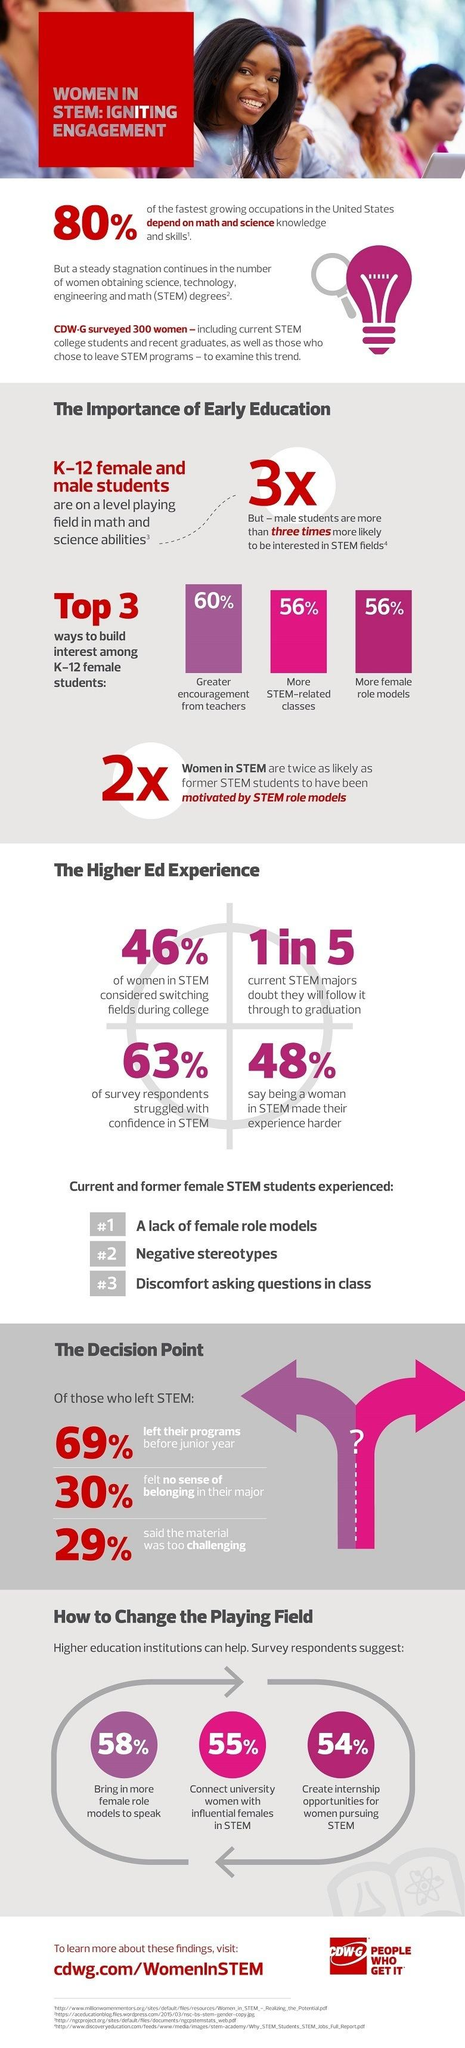List a handful of essential elements in this visual. According to a study, a significant percentage of STEM (Science, Technology, Engineering, and Mathematics) graduates quit their course in the initial year itself, with 69% of them doing so. The third problem faced by STEM graduates is difficulty in feeling comfortable asking questions in class. The second problem faced by STEM graduates is the prevalence of negative stereotypes that undermine their credibility and limit their opportunities. According to a survey of STEM graduates, 29% believed that their field was too challenging to handle. Si se trata de una pregunta en la que se preguntaba qué porcentaje de graduados de STEM (ciencias, tecnología, ingeniería y matemáticas) no estaban seguros de la programación, según una encuesta, el 63% de los graduados en STEM no estaban seguros de la programación. 